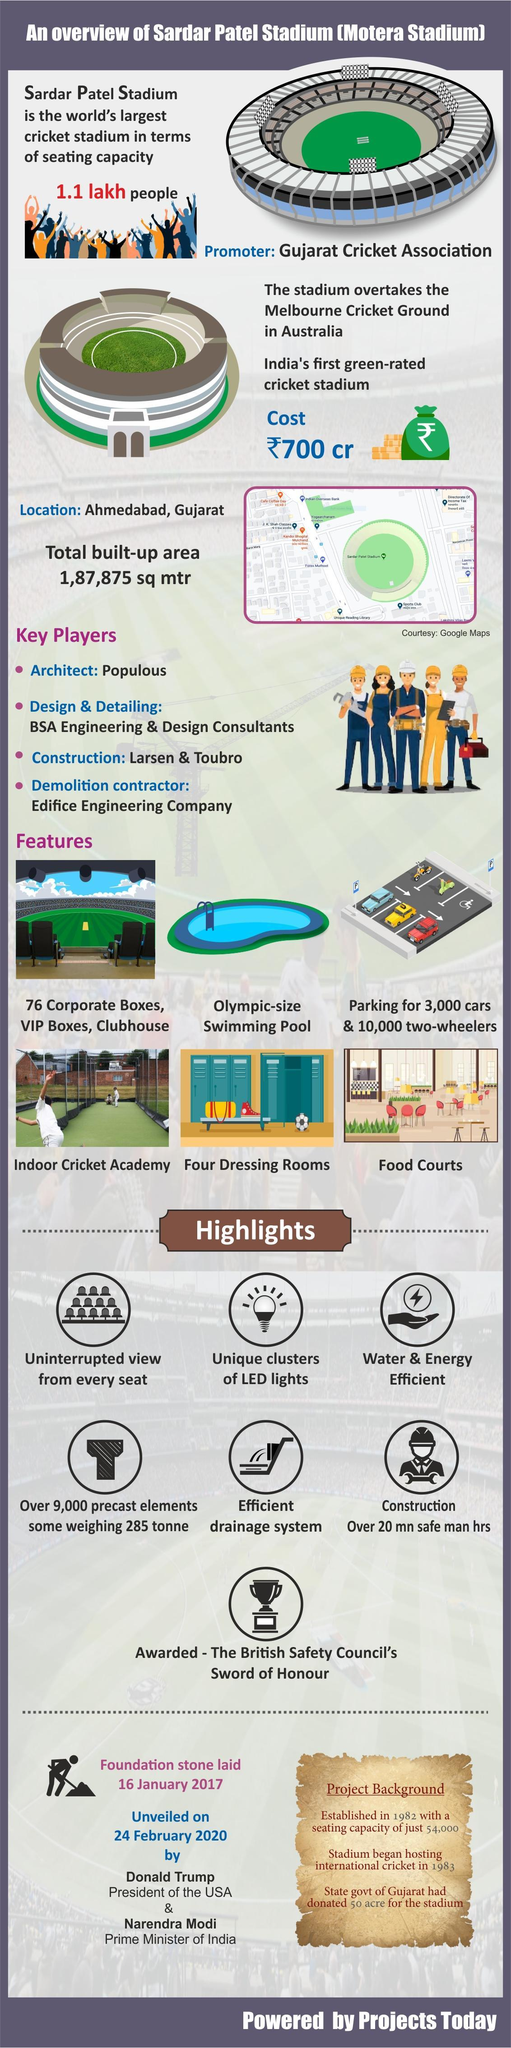How many people can be accommodated in the Sardar Patel Stadium?
Answer the question with a short phrase. 1.1 lakh people How much is the construction cost of Sardar Patel Stadium? ₹700 cr 